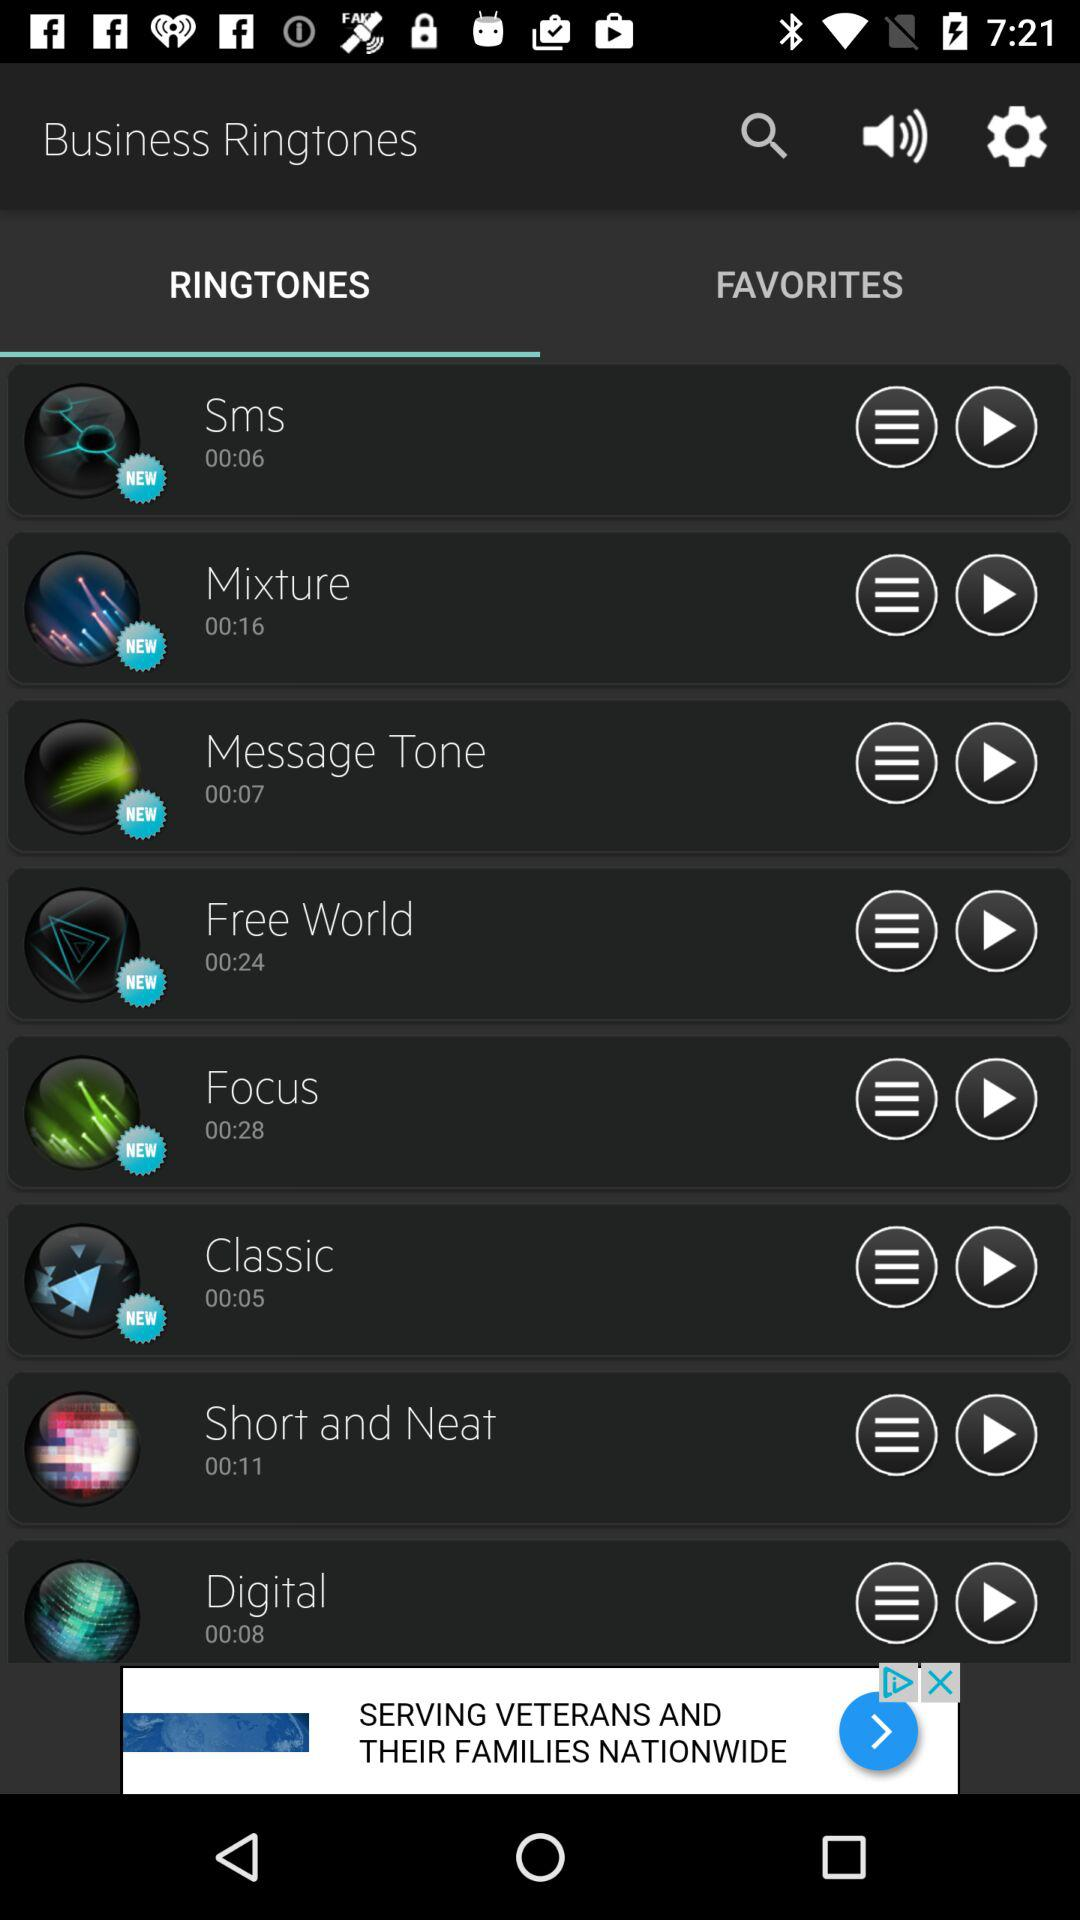Which ringtone has a duration of 11 seconds? The ringtone "Short and Neat" has a duration of 11 seconds. 